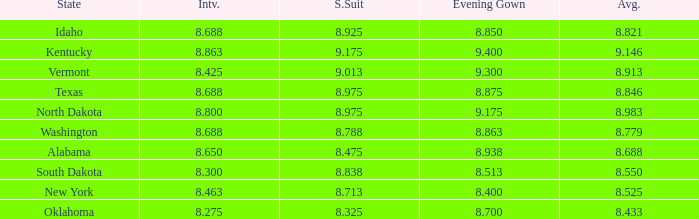What is the average interview score from Kentucky? 8.863. 